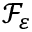Convert formula to latex. <formula><loc_0><loc_0><loc_500><loc_500>\mathcal { F } _ { \varepsilon }</formula> 